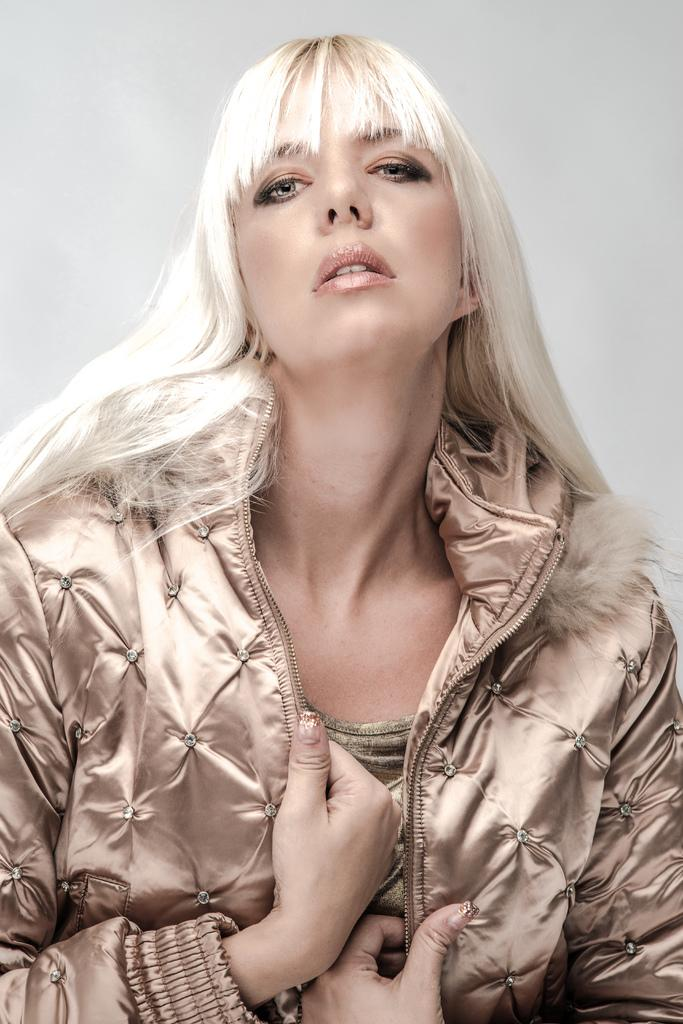Who is the main subject in the foreground of the image? There is a woman in the foreground of the image. Can you describe the woman's hair color? The woman has white hair. What type of clothing is the woman wearing? The woman is wearing a jacket. What level of the building is the woman cooking in the image? There is no indication in the image that the woman is cooking, nor is there any reference to a building. 